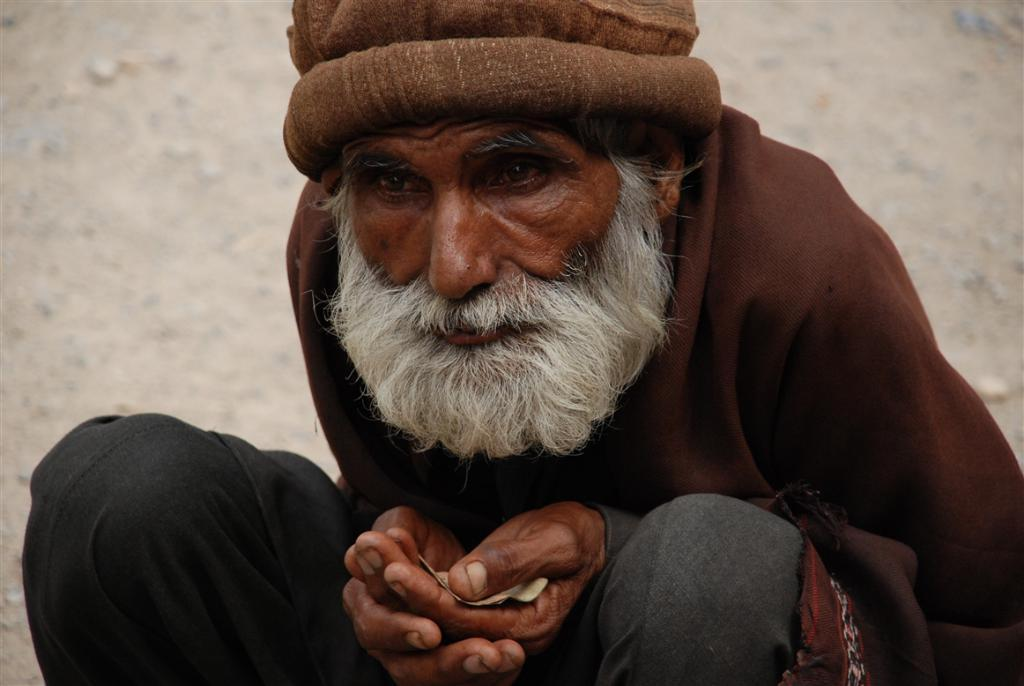Who is the main subject in the image? There is an old man in the image. Where is the old man located in the image? The old man is in the center of the image. What can be seen in the background of the image? There appears to be a wall in the background of the image. How many balloons are tied to the old man's wrist in the image? There are no balloons present in the image. What type of rock is the old man holding in the image? There is no rock present in the image. 